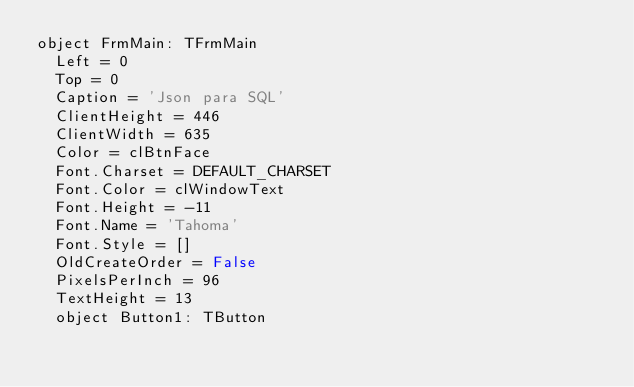<code> <loc_0><loc_0><loc_500><loc_500><_Pascal_>object FrmMain: TFrmMain
  Left = 0
  Top = 0
  Caption = 'Json para SQL'
  ClientHeight = 446
  ClientWidth = 635
  Color = clBtnFace
  Font.Charset = DEFAULT_CHARSET
  Font.Color = clWindowText
  Font.Height = -11
  Font.Name = 'Tahoma'
  Font.Style = []
  OldCreateOrder = False
  PixelsPerInch = 96
  TextHeight = 13
  object Button1: TButton</code> 